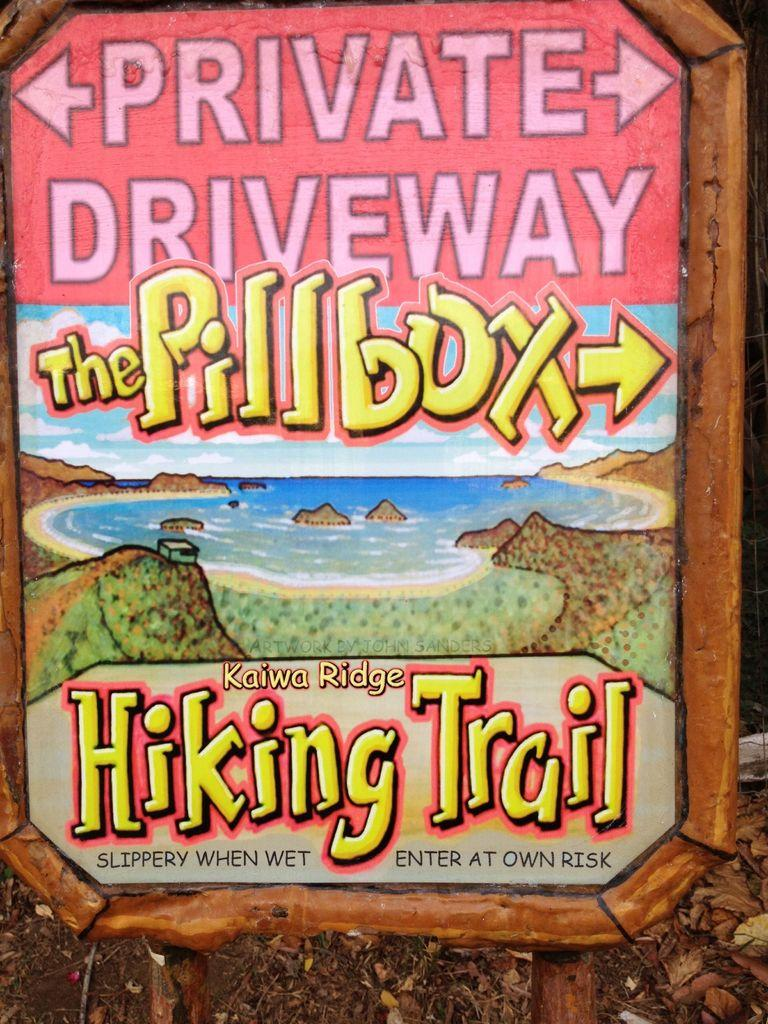Provide a one-sentence caption for the provided image. A sign that says the way to the pillbox hiking trail. 